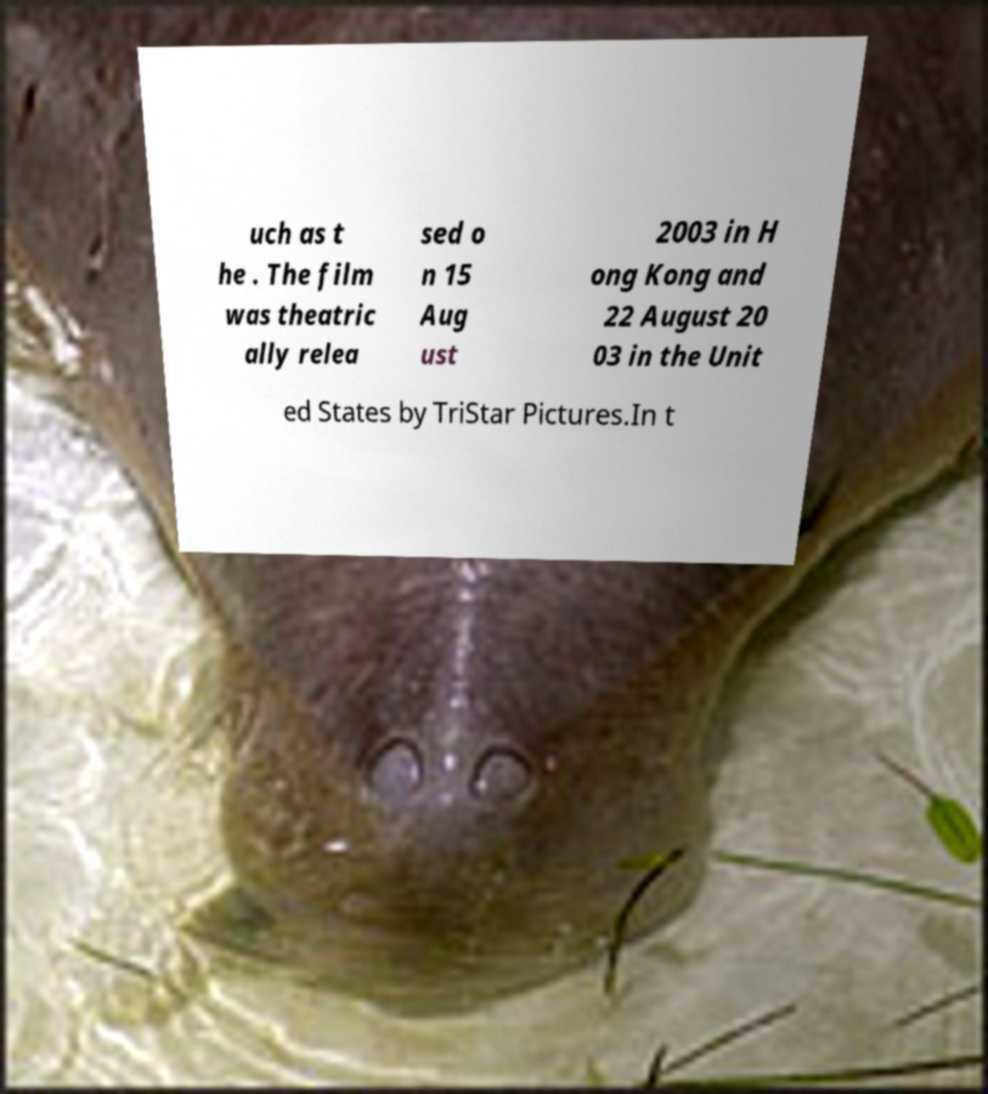Please read and relay the text visible in this image. What does it say? uch as t he . The film was theatric ally relea sed o n 15 Aug ust 2003 in H ong Kong and 22 August 20 03 in the Unit ed States by TriStar Pictures.In t 